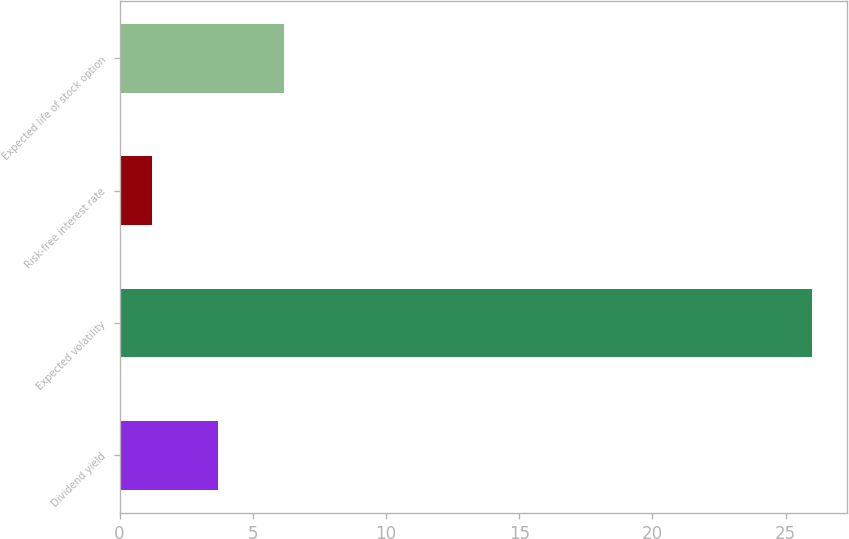Convert chart to OTSL. <chart><loc_0><loc_0><loc_500><loc_500><bar_chart><fcel>Dividend yield<fcel>Expected volatility<fcel>Risk-free interest rate<fcel>Expected life of stock option<nl><fcel>3.68<fcel>26<fcel>1.2<fcel>6.16<nl></chart> 